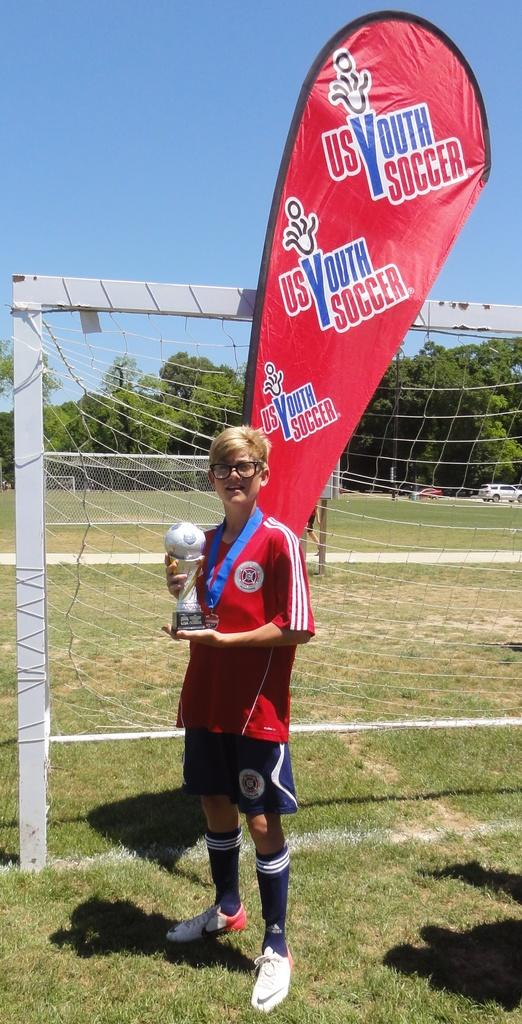<image>
Relay a brief, clear account of the picture shown. A young lady proudly holds her youth soccer trophy. 